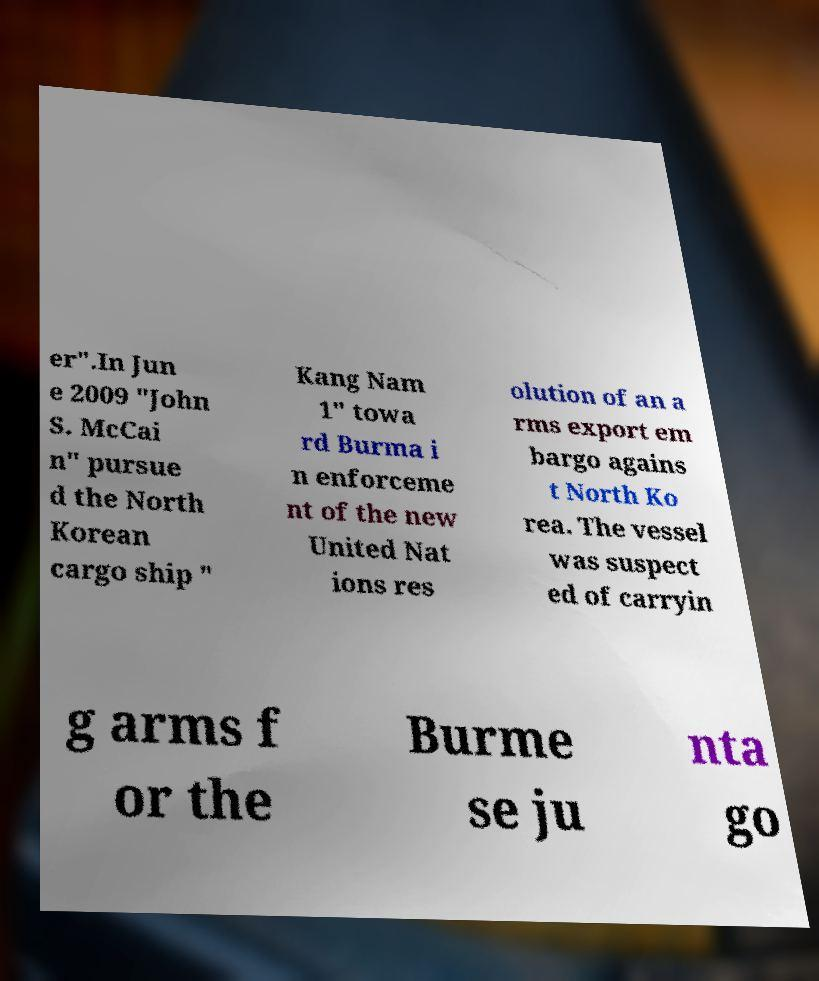Could you extract and type out the text from this image? er".In Jun e 2009 "John S. McCai n" pursue d the North Korean cargo ship " Kang Nam 1" towa rd Burma i n enforceme nt of the new United Nat ions res olution of an a rms export em bargo agains t North Ko rea. The vessel was suspect ed of carryin g arms f or the Burme se ju nta go 